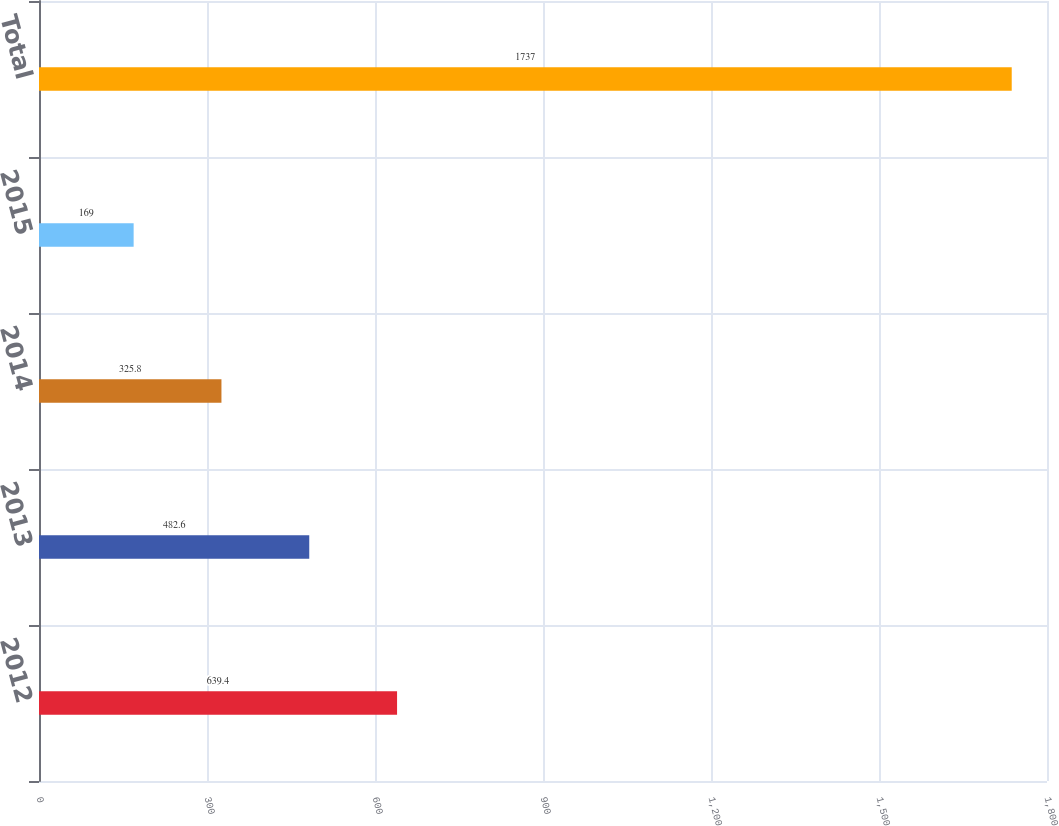Convert chart to OTSL. <chart><loc_0><loc_0><loc_500><loc_500><bar_chart><fcel>2012<fcel>2013<fcel>2014<fcel>2015<fcel>Total<nl><fcel>639.4<fcel>482.6<fcel>325.8<fcel>169<fcel>1737<nl></chart> 